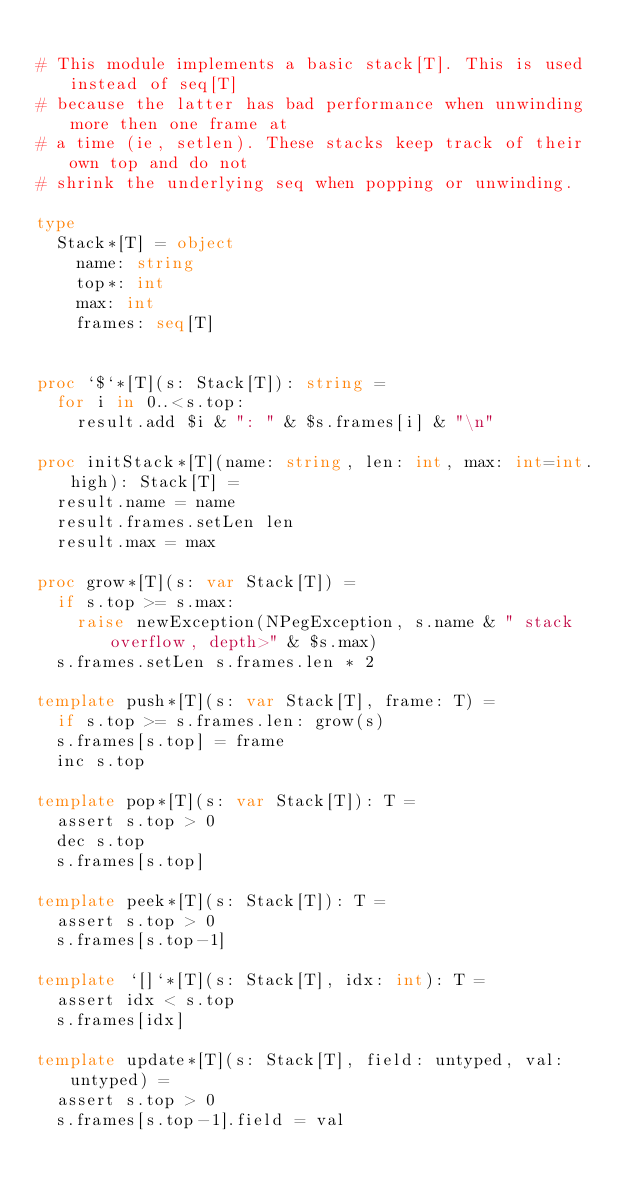<code> <loc_0><loc_0><loc_500><loc_500><_Nim_>
# This module implements a basic stack[T]. This is used instead of seq[T]
# because the latter has bad performance when unwinding more then one frame at
# a time (ie, setlen). These stacks keep track of their own top and do not
# shrink the underlying seq when popping or unwinding.

type
  Stack*[T] = object
    name: string
    top*: int
    max: int
    frames: seq[T]


proc `$`*[T](s: Stack[T]): string =
  for i in 0..<s.top:
    result.add $i & ": " & $s.frames[i] & "\n"

proc initStack*[T](name: string, len: int, max: int=int.high): Stack[T] =
  result.name = name
  result.frames.setLen len
  result.max = max

proc grow*[T](s: var Stack[T]) =
  if s.top >= s.max:
    raise newException(NPegException, s.name & " stack overflow, depth>" & $s.max)
  s.frames.setLen s.frames.len * 2

template push*[T](s: var Stack[T], frame: T) =
  if s.top >= s.frames.len: grow(s)
  s.frames[s.top] = frame
  inc s.top

template pop*[T](s: var Stack[T]): T =
  assert s.top > 0
  dec s.top
  s.frames[s.top]

template peek*[T](s: Stack[T]): T =
  assert s.top > 0
  s.frames[s.top-1]

template `[]`*[T](s: Stack[T], idx: int): T =
  assert idx < s.top
  s.frames[idx]

template update*[T](s: Stack[T], field: untyped, val: untyped) =
  assert s.top > 0
  s.frames[s.top-1].field = val

</code> 